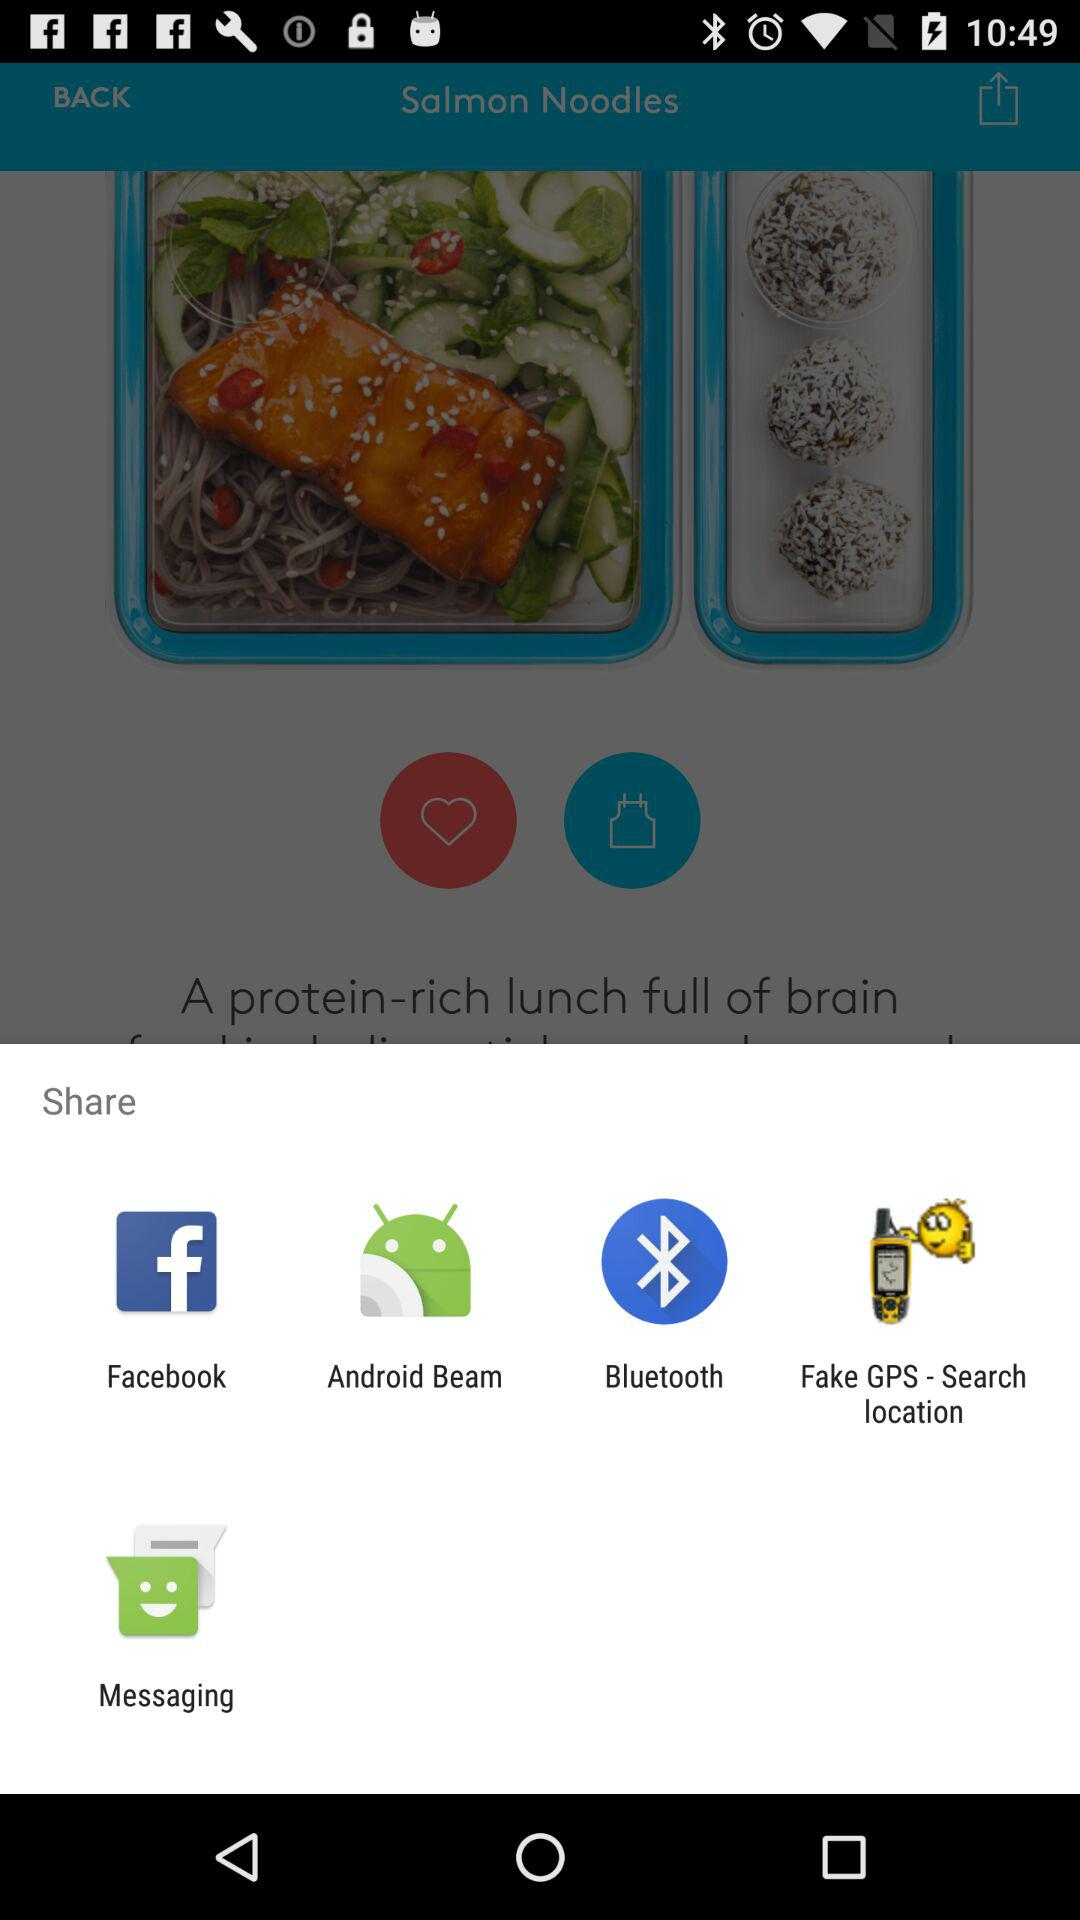Which apps can we use to share? You can use "Facebook", "Android Beam", "Bluetooth", "Fake GPS - Search location" and "Messaging" to share. 